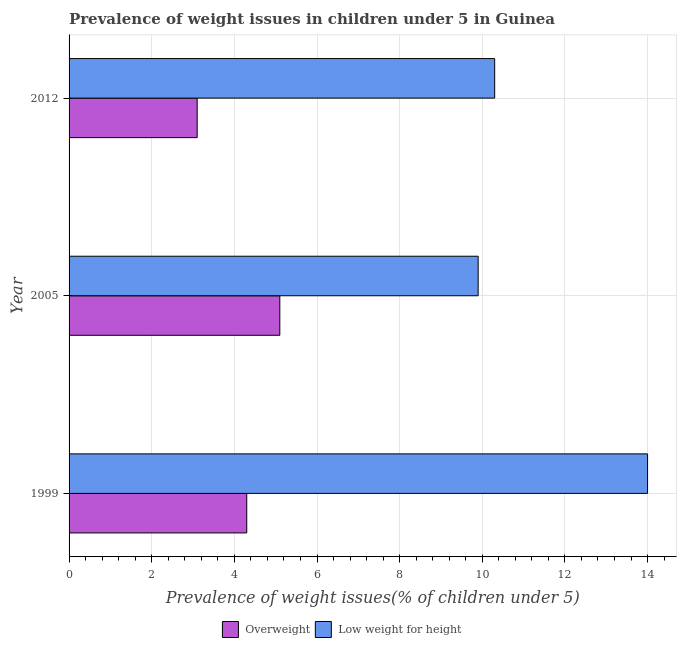How many bars are there on the 3rd tick from the top?
Your answer should be very brief. 2. How many bars are there on the 3rd tick from the bottom?
Give a very brief answer. 2. What is the label of the 2nd group of bars from the top?
Provide a short and direct response. 2005. In how many cases, is the number of bars for a given year not equal to the number of legend labels?
Keep it short and to the point. 0. What is the percentage of underweight children in 2012?
Provide a succinct answer. 10.3. Across all years, what is the minimum percentage of underweight children?
Keep it short and to the point. 9.9. In which year was the percentage of overweight children maximum?
Your response must be concise. 2005. In which year was the percentage of underweight children minimum?
Your answer should be very brief. 2005. What is the total percentage of overweight children in the graph?
Ensure brevity in your answer.  12.5. What is the difference between the percentage of underweight children in 1999 and that in 2012?
Offer a terse response. 3.7. What is the difference between the percentage of underweight children in 2005 and the percentage of overweight children in 1999?
Provide a short and direct response. 5.6. What is the average percentage of underweight children per year?
Give a very brief answer. 11.4. In the year 2005, what is the difference between the percentage of underweight children and percentage of overweight children?
Your response must be concise. 4.8. In how many years, is the percentage of underweight children greater than 4.8 %?
Make the answer very short. 3. What is the ratio of the percentage of underweight children in 1999 to that in 2012?
Ensure brevity in your answer.  1.36. Is the percentage of overweight children in 1999 less than that in 2012?
Offer a very short reply. No. Is the sum of the percentage of overweight children in 1999 and 2012 greater than the maximum percentage of underweight children across all years?
Your response must be concise. No. What does the 1st bar from the top in 2005 represents?
Offer a terse response. Low weight for height. What does the 2nd bar from the bottom in 2005 represents?
Your answer should be compact. Low weight for height. How many bars are there?
Your response must be concise. 6. How many years are there in the graph?
Your response must be concise. 3. What is the difference between two consecutive major ticks on the X-axis?
Offer a very short reply. 2. Are the values on the major ticks of X-axis written in scientific E-notation?
Offer a very short reply. No. Does the graph contain any zero values?
Ensure brevity in your answer.  No. Where does the legend appear in the graph?
Ensure brevity in your answer.  Bottom center. How many legend labels are there?
Your answer should be very brief. 2. How are the legend labels stacked?
Ensure brevity in your answer.  Horizontal. What is the title of the graph?
Keep it short and to the point. Prevalence of weight issues in children under 5 in Guinea. Does "Girls" appear as one of the legend labels in the graph?
Ensure brevity in your answer.  No. What is the label or title of the X-axis?
Your response must be concise. Prevalence of weight issues(% of children under 5). What is the Prevalence of weight issues(% of children under 5) of Overweight in 1999?
Ensure brevity in your answer.  4.3. What is the Prevalence of weight issues(% of children under 5) in Low weight for height in 1999?
Provide a short and direct response. 14. What is the Prevalence of weight issues(% of children under 5) in Overweight in 2005?
Make the answer very short. 5.1. What is the Prevalence of weight issues(% of children under 5) of Low weight for height in 2005?
Offer a very short reply. 9.9. What is the Prevalence of weight issues(% of children under 5) in Overweight in 2012?
Provide a succinct answer. 3.1. What is the Prevalence of weight issues(% of children under 5) in Low weight for height in 2012?
Give a very brief answer. 10.3. Across all years, what is the maximum Prevalence of weight issues(% of children under 5) of Overweight?
Ensure brevity in your answer.  5.1. Across all years, what is the minimum Prevalence of weight issues(% of children under 5) in Overweight?
Keep it short and to the point. 3.1. Across all years, what is the minimum Prevalence of weight issues(% of children under 5) in Low weight for height?
Ensure brevity in your answer.  9.9. What is the total Prevalence of weight issues(% of children under 5) of Low weight for height in the graph?
Give a very brief answer. 34.2. What is the difference between the Prevalence of weight issues(% of children under 5) in Low weight for height in 1999 and that in 2005?
Provide a short and direct response. 4.1. What is the difference between the Prevalence of weight issues(% of children under 5) in Overweight in 1999 and that in 2012?
Provide a short and direct response. 1.2. What is the difference between the Prevalence of weight issues(% of children under 5) in Low weight for height in 1999 and that in 2012?
Make the answer very short. 3.7. What is the difference between the Prevalence of weight issues(% of children under 5) in Overweight in 2005 and that in 2012?
Offer a very short reply. 2. What is the difference between the Prevalence of weight issues(% of children under 5) of Low weight for height in 2005 and that in 2012?
Offer a very short reply. -0.4. What is the difference between the Prevalence of weight issues(% of children under 5) of Overweight in 1999 and the Prevalence of weight issues(% of children under 5) of Low weight for height in 2012?
Your answer should be compact. -6. What is the average Prevalence of weight issues(% of children under 5) of Overweight per year?
Provide a short and direct response. 4.17. What is the average Prevalence of weight issues(% of children under 5) of Low weight for height per year?
Provide a succinct answer. 11.4. In the year 2005, what is the difference between the Prevalence of weight issues(% of children under 5) of Overweight and Prevalence of weight issues(% of children under 5) of Low weight for height?
Your answer should be very brief. -4.8. What is the ratio of the Prevalence of weight issues(% of children under 5) of Overweight in 1999 to that in 2005?
Ensure brevity in your answer.  0.84. What is the ratio of the Prevalence of weight issues(% of children under 5) in Low weight for height in 1999 to that in 2005?
Keep it short and to the point. 1.41. What is the ratio of the Prevalence of weight issues(% of children under 5) in Overweight in 1999 to that in 2012?
Offer a terse response. 1.39. What is the ratio of the Prevalence of weight issues(% of children under 5) in Low weight for height in 1999 to that in 2012?
Give a very brief answer. 1.36. What is the ratio of the Prevalence of weight issues(% of children under 5) in Overweight in 2005 to that in 2012?
Keep it short and to the point. 1.65. What is the ratio of the Prevalence of weight issues(% of children under 5) in Low weight for height in 2005 to that in 2012?
Provide a short and direct response. 0.96. What is the difference between the highest and the second highest Prevalence of weight issues(% of children under 5) of Overweight?
Ensure brevity in your answer.  0.8. What is the difference between the highest and the second highest Prevalence of weight issues(% of children under 5) in Low weight for height?
Your answer should be very brief. 3.7. What is the difference between the highest and the lowest Prevalence of weight issues(% of children under 5) in Overweight?
Your response must be concise. 2. What is the difference between the highest and the lowest Prevalence of weight issues(% of children under 5) in Low weight for height?
Make the answer very short. 4.1. 